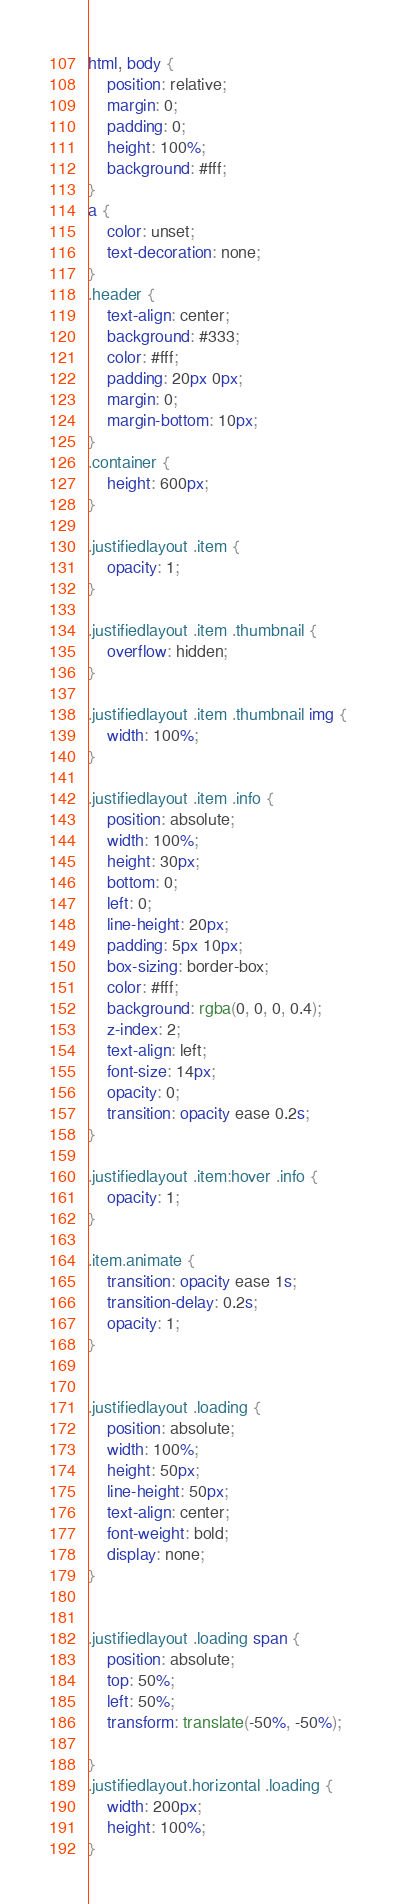Convert code to text. <code><loc_0><loc_0><loc_500><loc_500><_CSS_>html, body {
    position: relative;
    margin: 0;
    padding: 0;
    height: 100%;
    background: #fff;
}
a {
    color: unset;
    text-decoration: none;
}
.header {
    text-align: center;
    background: #333;
    color: #fff;
    padding: 20px 0px;
    margin: 0;
    margin-bottom: 10px;
}
.container {
    height: 600px;
}

.justifiedlayout .item {
    opacity: 1;
}

.justifiedlayout .item .thumbnail {
    overflow: hidden;
}

.justifiedlayout .item .thumbnail img {
    width: 100%;
}

.justifiedlayout .item .info {
    position: absolute;
    width: 100%;
    height: 30px;
    bottom: 0;
    left: 0;
    line-height: 20px;
    padding: 5px 10px;
    box-sizing: border-box;
    color: #fff;
    background: rgba(0, 0, 0, 0.4);
    z-index: 2;
    text-align: left;
    font-size: 14px;
    opacity: 0;
    transition: opacity ease 0.2s;
}

.justifiedlayout .item:hover .info {
    opacity: 1;
}

.item.animate {
    transition: opacity ease 1s;
    transition-delay: 0.2s;
    opacity: 1;
}


.justifiedlayout .loading {
    position: absolute;
    width: 100%;
    height: 50px;
    line-height: 50px;
    text-align: center;
    font-weight: bold;
    display: none;
}


.justifiedlayout .loading span {
    position: absolute;
    top: 50%;
    left: 50%;
    transform: translate(-50%, -50%);

}
.justifiedlayout.horizontal .loading {
    width: 200px;
    height: 100%;
}
</code> 